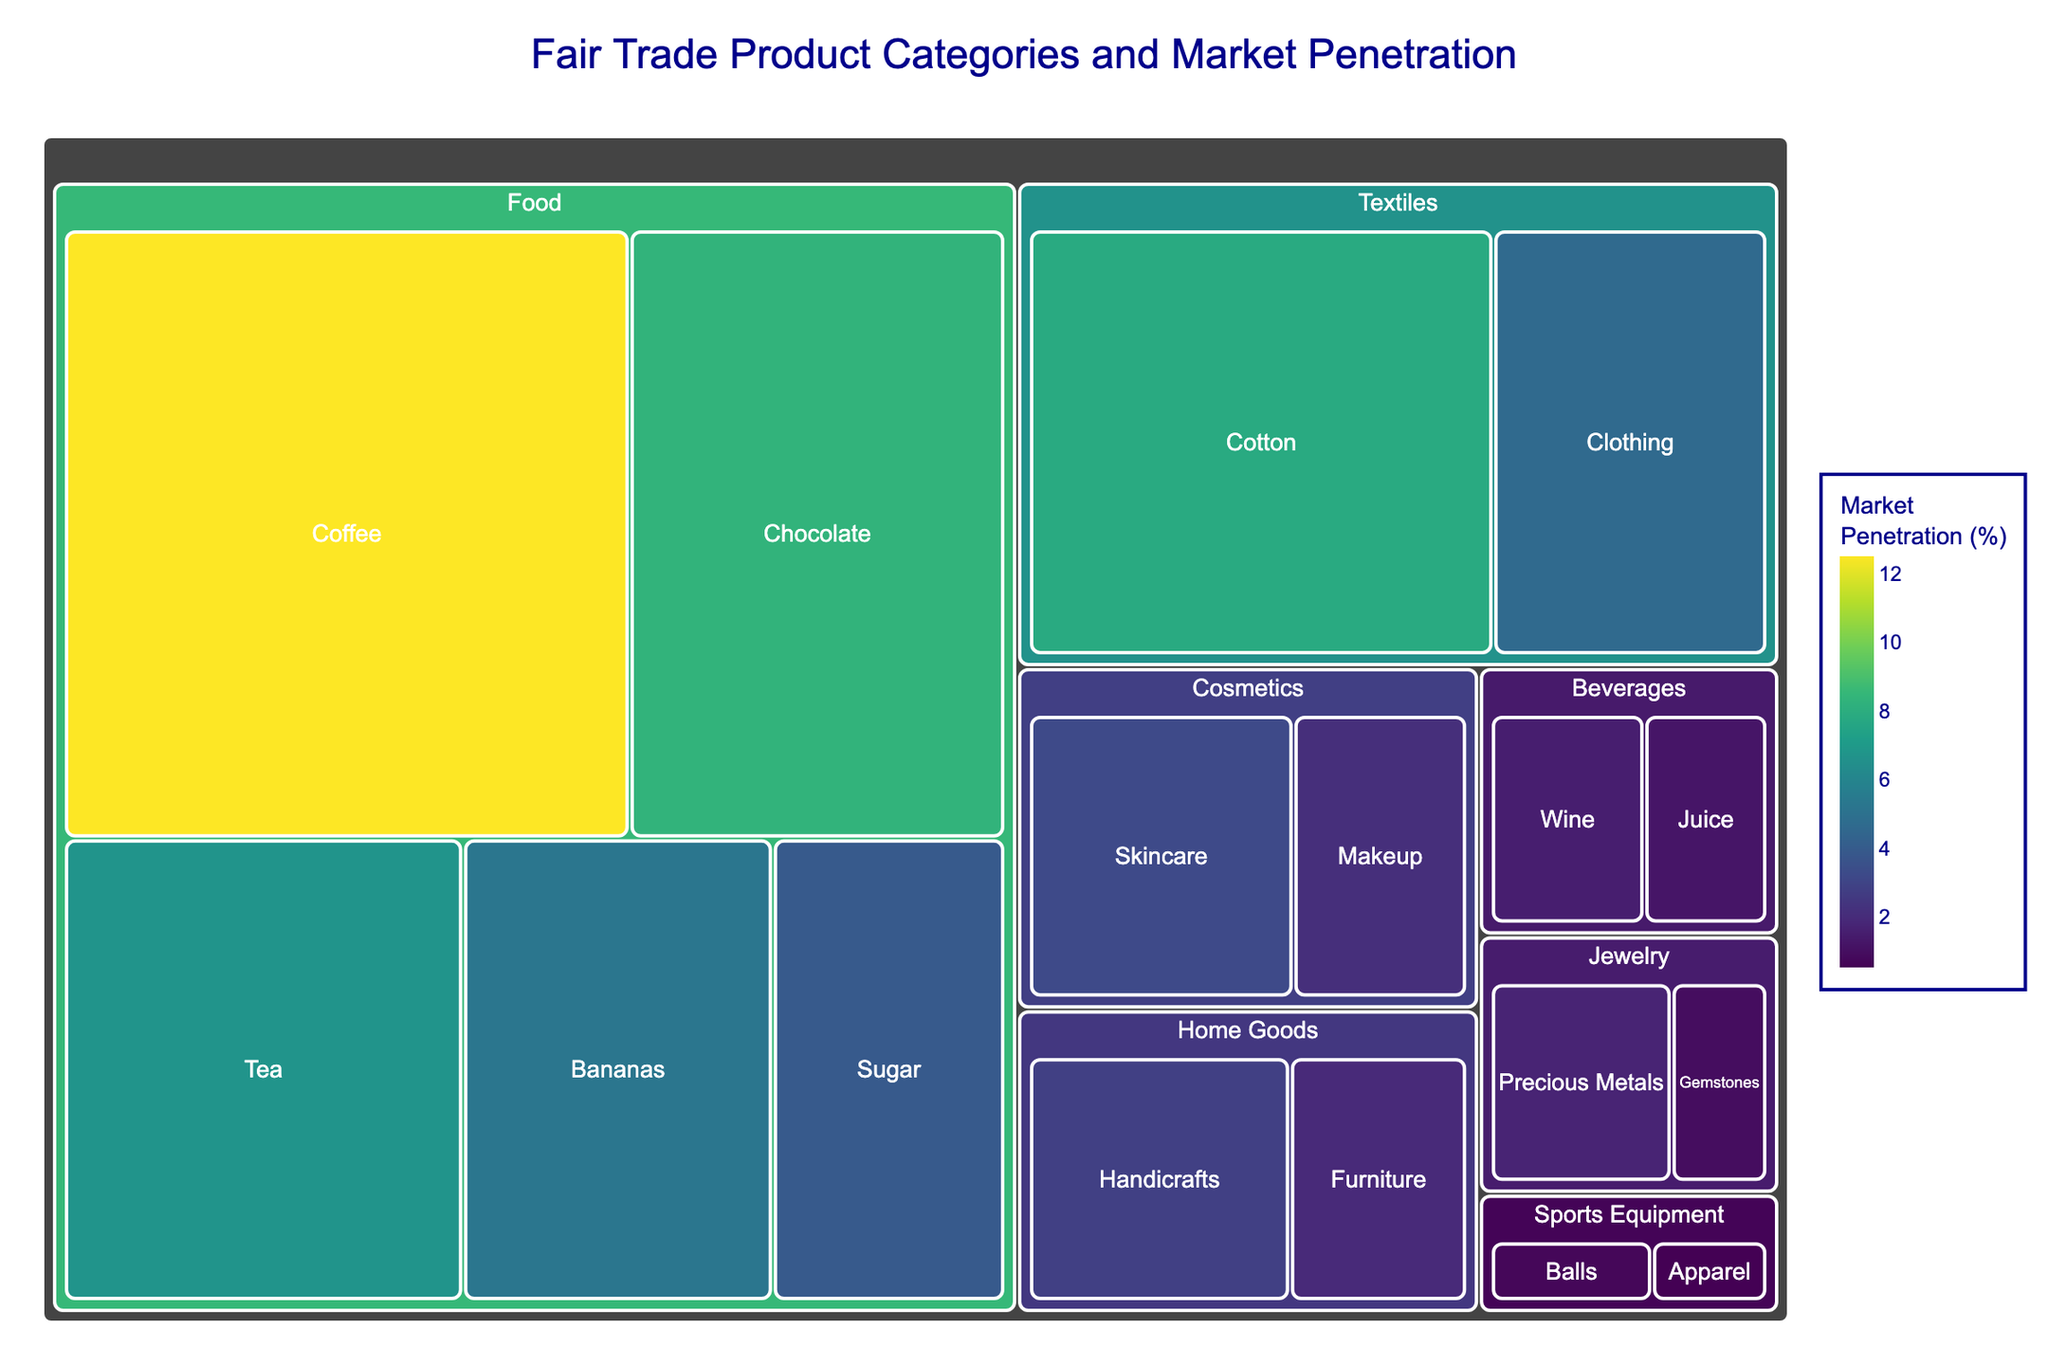What is the category with the highest market penetration? The treemap shows various categories and their respective market penetrations. By visually assessing the sizes of the subcategories, we can determine that the "Food" category, specifically the "Coffee" subcategory, has the highest market penetration of 12.5%
Answer: Food (Coffee) How many categories have a market penetration above 5%? By examining the treemap, we can identify and count the subcategories with market penetrations exceeding 5%. These are Coffee (12.5%), Chocolate (8.3%), Tea (6.7%), Bananas (5.2%), and Cotton (7.8%)
Answer: 5 Which subcategory has the lowest market penetration? Looking at the treemap, the smallest box and the lowest value indicated belongs to the "Sports Equipment" category, specifically "Apparel," which has a market penetration of 0.5%
Answer: Sports Equipment (Apparel) How does the market penetration of fair trade Cotton compare to that of fair trade Chocolate? To compare, we locate both "Cotton" (7.8%) under "Textiles" and "Chocolate" (8.3%) under "Food" in the treemap. By comparing the two values, we see that Chocolate has a slightly higher market penetration than Cotton
Answer: Chocolate is higher What is the combined market penetration of all Home Goods subcategories? The treemap depicts two subcategories under "Home Goods": Handicrafts (2.8%) and Furniture (1.9%). Adding these values together gives 2.8% + 1.9% = 4.7%
Answer: 4.7% Which product category is more penetrated, Cosmetics or Beverages? We sum the market penetrations of subcategories under each category. Cosmetics has Skincare (3.2%) and Makeup (2.1%), totaling 5.3%. Beverages has Wine (1.5%) and Juice (1.2%), totaling 2.7%. Cosmetics, having a higher combined total, is more penetrated
Answer: Cosmetics What is the market penetration range for all the fair trade products? To determine the range, we find the highest and lowest market penetration values from the treemap. The highest is Coffee (12.5%) and the lowest is Sports Equipment (Apparel - 0.5%). The range is 12.5% - 0.5% = 12%
Answer: 12% Which category has a more diverse range of subproduct penetrations, Food or Textiles? First, we assess the spread of market penetration values in each category. Food ranges from Coffee (12.5%) to Sugar (3.9%), a spread of 12.5% - 3.9% = 8.6%. Textiles ranges from Cotton (7.8%) to Clothing (4.6%), a spread of 7.8% - 4.6% = 3.2%. Thus, Food has a more diverse range
Answer: Food 